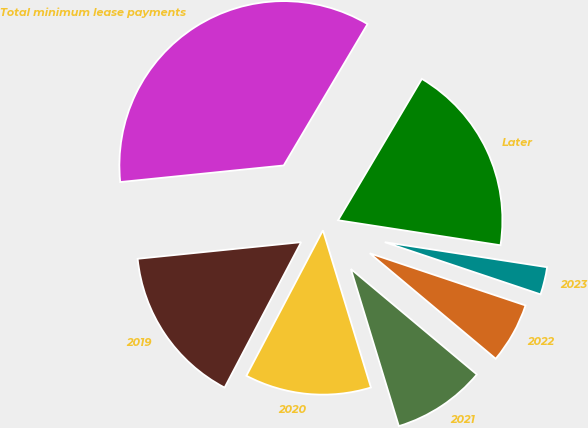Convert chart to OTSL. <chart><loc_0><loc_0><loc_500><loc_500><pie_chart><fcel>2019<fcel>2020<fcel>2021<fcel>2022<fcel>2023<fcel>Later<fcel>Total minimum lease payments<nl><fcel>15.68%<fcel>12.43%<fcel>9.19%<fcel>5.95%<fcel>2.71%<fcel>18.92%<fcel>35.13%<nl></chart> 